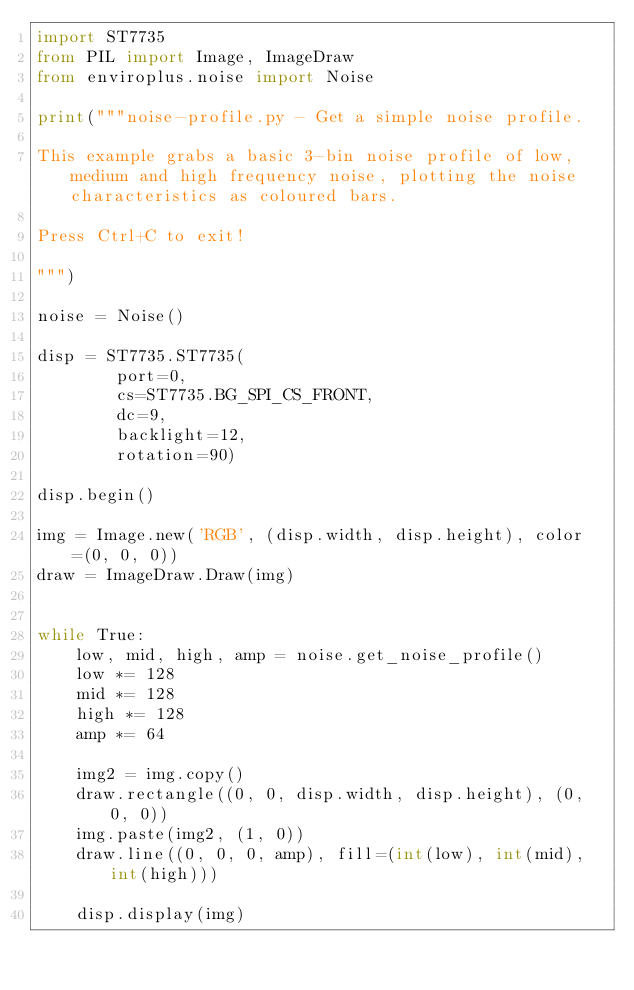Convert code to text. <code><loc_0><loc_0><loc_500><loc_500><_Python_>import ST7735
from PIL import Image, ImageDraw
from enviroplus.noise import Noise

print("""noise-profile.py - Get a simple noise profile.

This example grabs a basic 3-bin noise profile of low, medium and high frequency noise, plotting the noise characteristics as coloured bars.

Press Ctrl+C to exit!

""")

noise = Noise()

disp = ST7735.ST7735(
        port=0,
        cs=ST7735.BG_SPI_CS_FRONT,
        dc=9,
        backlight=12,
        rotation=90)

disp.begin()

img = Image.new('RGB', (disp.width, disp.height), color=(0, 0, 0))
draw = ImageDraw.Draw(img)


while True:
    low, mid, high, amp = noise.get_noise_profile()
    low *= 128
    mid *= 128
    high *= 128
    amp *= 64

    img2 = img.copy()
    draw.rectangle((0, 0, disp.width, disp.height), (0, 0, 0))
    img.paste(img2, (1, 0))
    draw.line((0, 0, 0, amp), fill=(int(low), int(mid), int(high)))

    disp.display(img)
</code> 